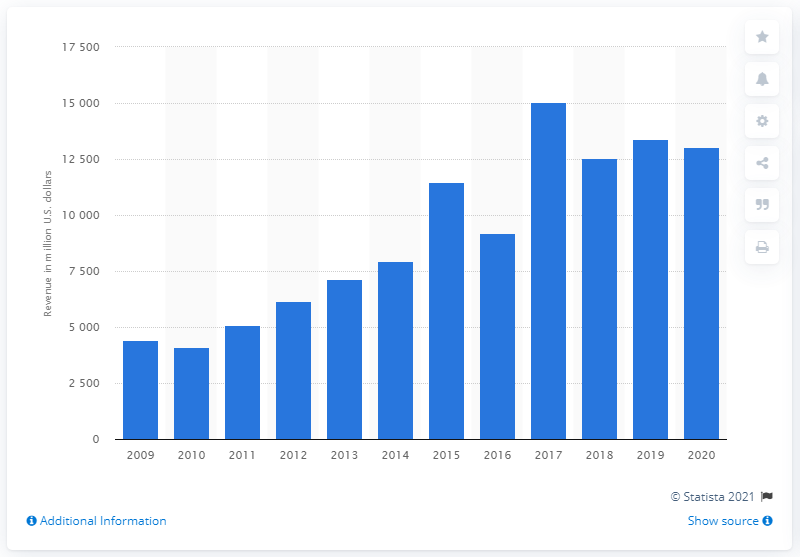Give some essential details in this illustration. In 2020, TechnipFMC's revenue was approximately $130,506. 